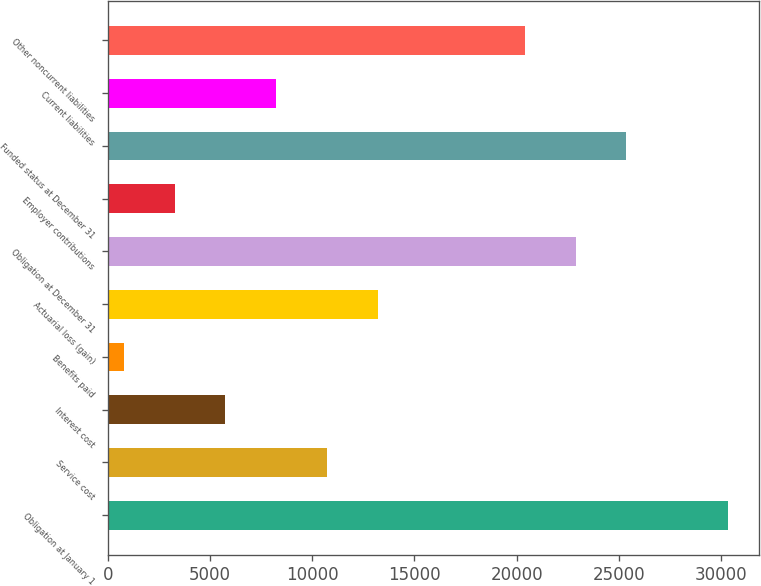Convert chart to OTSL. <chart><loc_0><loc_0><loc_500><loc_500><bar_chart><fcel>Obligation at January 1<fcel>Service cost<fcel>Interest cost<fcel>Benefits paid<fcel>Actuarial loss (gain)<fcel>Obligation at December 31<fcel>Employer contributions<fcel>Funded status at December 31<fcel>Current liabilities<fcel>Other noncurrent liabilities<nl><fcel>30322.4<fcel>10715.4<fcel>5758.2<fcel>801<fcel>13194<fcel>22886.6<fcel>3279.6<fcel>25365.2<fcel>8236.8<fcel>20408<nl></chart> 